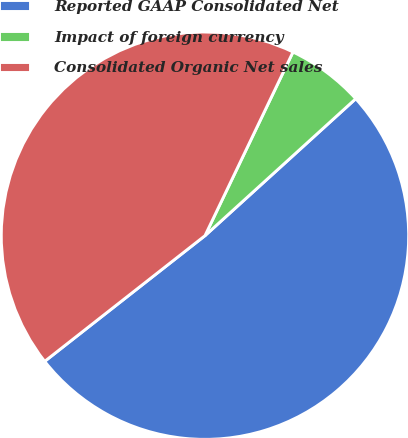Convert chart. <chart><loc_0><loc_0><loc_500><loc_500><pie_chart><fcel>Reported GAAP Consolidated Net<fcel>Impact of foreign currency<fcel>Consolidated Organic Net sales<nl><fcel>51.15%<fcel>6.15%<fcel>42.69%<nl></chart> 